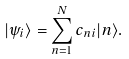Convert formula to latex. <formula><loc_0><loc_0><loc_500><loc_500>| \psi _ { i } \rangle = \sum _ { n = 1 } ^ { N } c _ { n i } | n \rangle .</formula> 